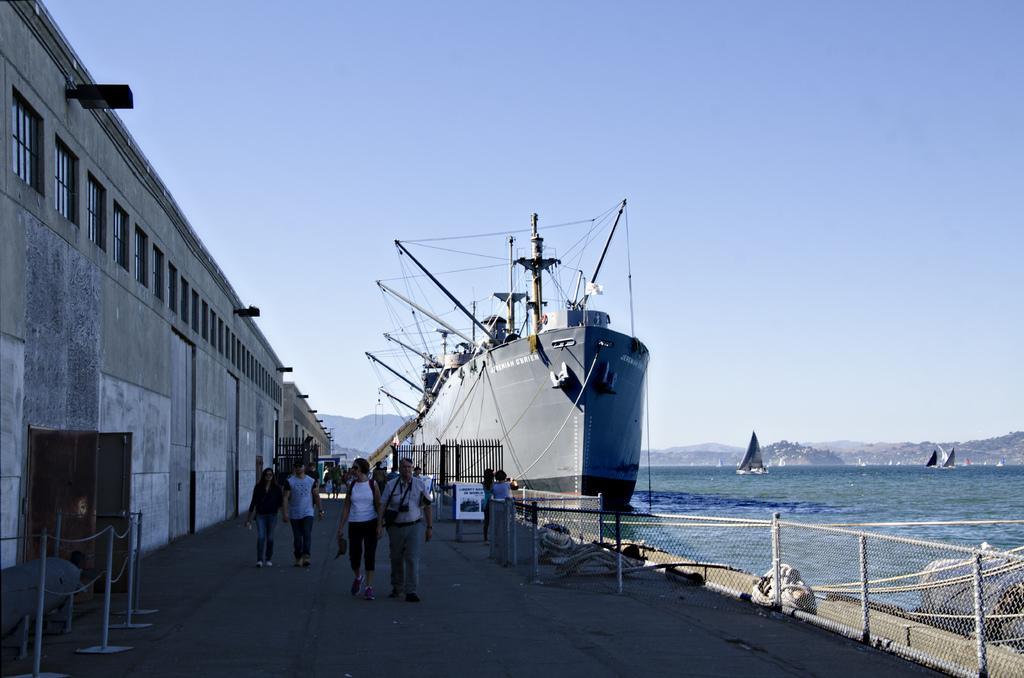Could you give a brief overview of what you see in this image? This image is clicked on the road. There are people walking on the road. To the left there is a wall of the house. There are windows and lights to the wall. In the bottom left there is a door to the wall. There is a railing near the door. On the other side of the road there is a railing. Behind the railing there is the water. There is a ship on the water. In the background there are mountains and boats on the water. At the top there is the sky. 